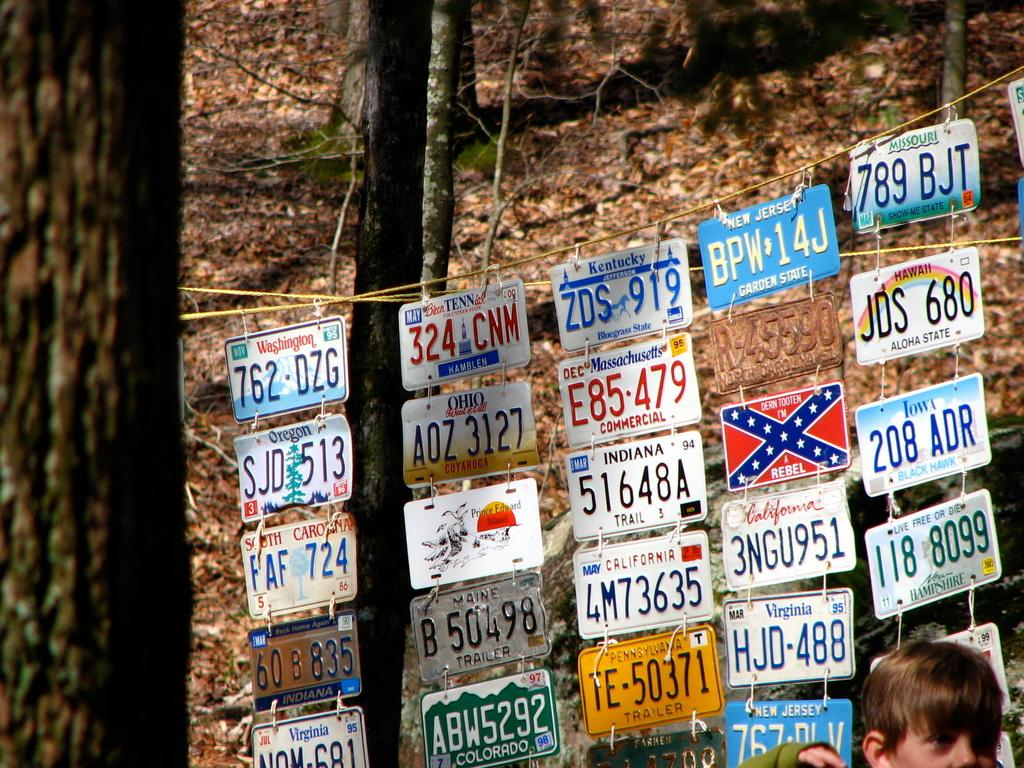What is hanging on a rope in the image? There are number plates hanging on a rope in the image. Can you describe the person in the image? There is a person in the image, but their appearance or actions are not specified. What can be seen in the background of the image? Trees and dry leaves are visible in the background of the image. What type of lettuce is being harvested by the person in the image? There is no lettuce present in the image, nor is there any indication of a person harvesting anything. Can you tell me how many airplanes are flying in the sky in the image? There is no mention of airplanes or a sky in the image; it features number plates hanging on a rope. 